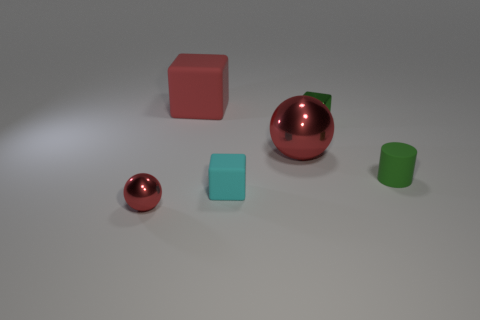Is the number of large green rubber cylinders greater than the number of small metallic balls?
Make the answer very short. No. Do the red block and the cyan object have the same material?
Your answer should be compact. Yes. How many objects are the same material as the big red block?
Offer a very short reply. 2. Do the green matte cylinder and the matte cube behind the tiny green matte cylinder have the same size?
Keep it short and to the point. No. There is a object that is in front of the large red rubber cube and on the left side of the cyan rubber thing; what is its color?
Your answer should be very brief. Red. There is a big object on the left side of the big metal ball; is there a tiny matte object behind it?
Your response must be concise. No. Is the number of small red balls behind the small green metallic cube the same as the number of big brown rubber cylinders?
Offer a terse response. Yes. What number of metal blocks are left of the matte cube behind the red metallic object right of the tiny ball?
Give a very brief answer. 0. Is there a purple rubber thing of the same size as the green block?
Keep it short and to the point. No. Are there fewer red metal spheres that are to the left of the green block than cyan matte cylinders?
Keep it short and to the point. No. 